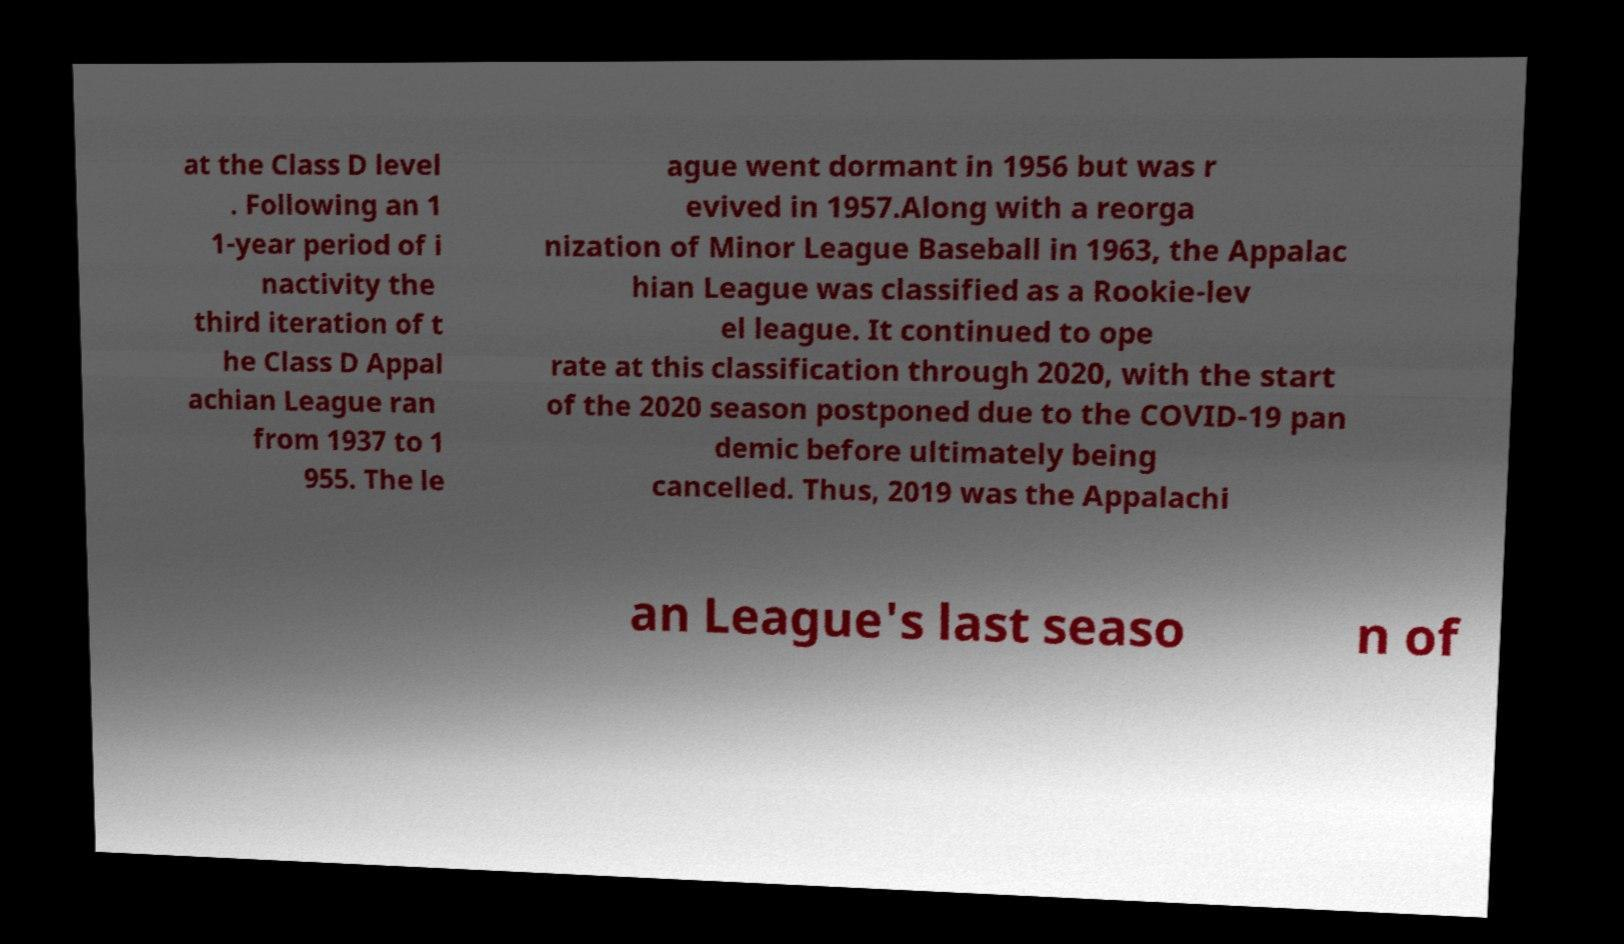What messages or text are displayed in this image? I need them in a readable, typed format. at the Class D level . Following an 1 1-year period of i nactivity the third iteration of t he Class D Appal achian League ran from 1937 to 1 955. The le ague went dormant in 1956 but was r evived in 1957.Along with a reorga nization of Minor League Baseball in 1963, the Appalac hian League was classified as a Rookie-lev el league. It continued to ope rate at this classification through 2020, with the start of the 2020 season postponed due to the COVID-19 pan demic before ultimately being cancelled. Thus, 2019 was the Appalachi an League's last seaso n of 